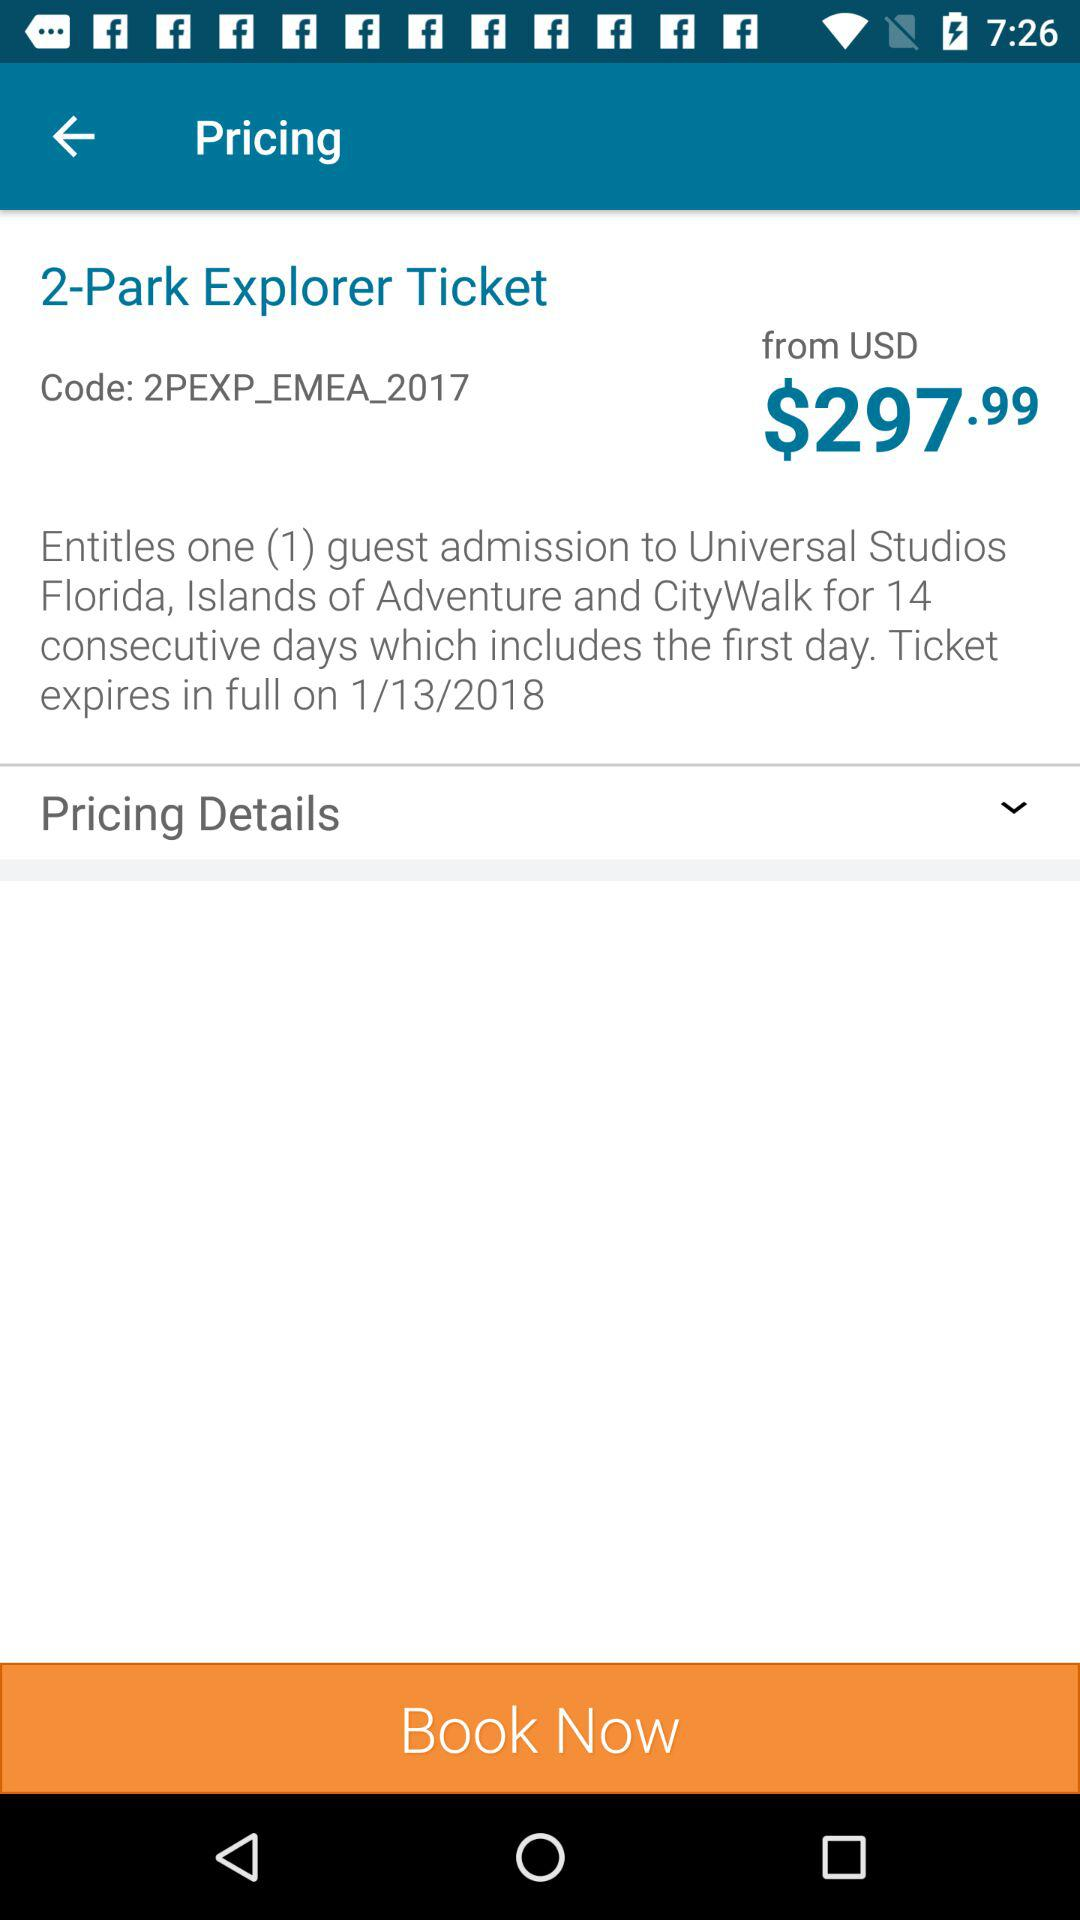What is the name of the ticket? The name of the ticket is "2-Park Explorer Ticket". 